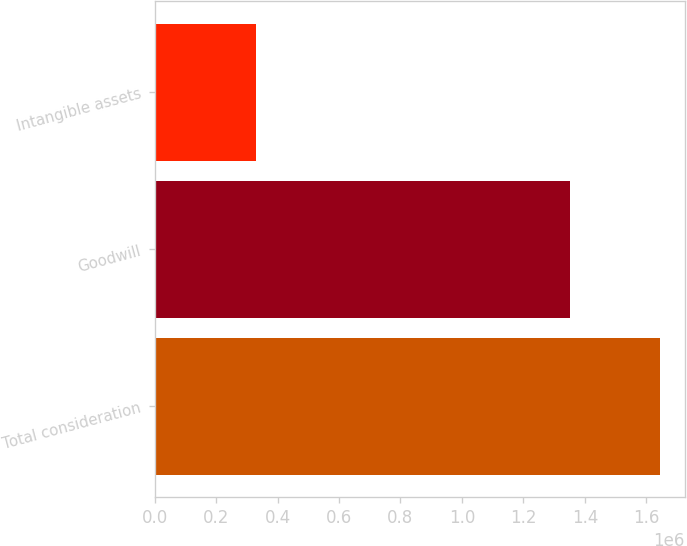<chart> <loc_0><loc_0><loc_500><loc_500><bar_chart><fcel>Total consideration<fcel>Goodwill<fcel>Intangible assets<nl><fcel>1.6432e+06<fcel>1.35097e+06<fcel>328776<nl></chart> 